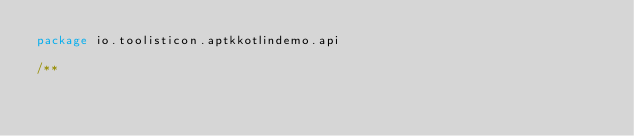<code> <loc_0><loc_0><loc_500><loc_500><_Kotlin_>package io.toolisticon.aptkkotlindemo.api

/**</code> 